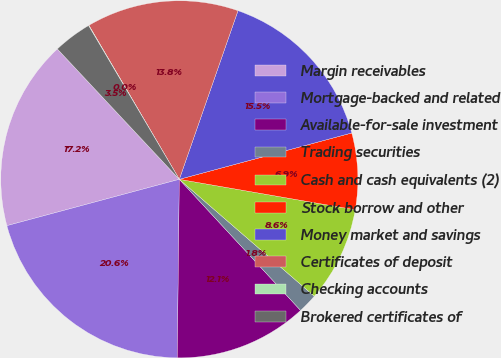Convert chart to OTSL. <chart><loc_0><loc_0><loc_500><loc_500><pie_chart><fcel>Margin receivables<fcel>Mortgage-backed and related<fcel>Available-for-sale investment<fcel>Trading securities<fcel>Cash and cash equivalents (2)<fcel>Stock borrow and other<fcel>Money market and savings<fcel>Certificates of deposit<fcel>Checking accounts<fcel>Brokered certificates of<nl><fcel>17.21%<fcel>20.64%<fcel>12.06%<fcel>1.76%<fcel>8.63%<fcel>6.91%<fcel>15.49%<fcel>13.78%<fcel>0.04%<fcel>3.48%<nl></chart> 